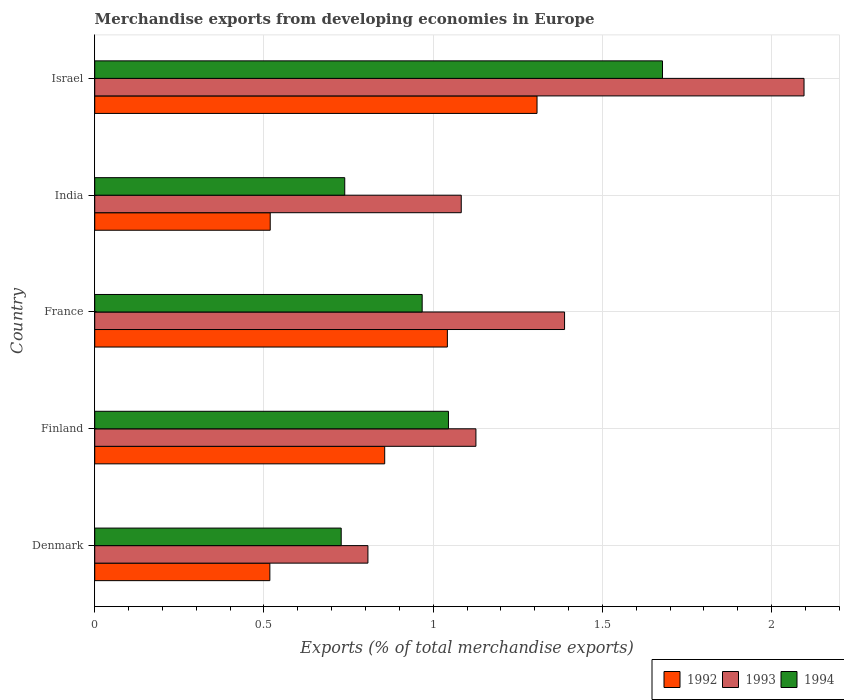How many different coloured bars are there?
Your response must be concise. 3. Are the number of bars per tick equal to the number of legend labels?
Your answer should be compact. Yes. Are the number of bars on each tick of the Y-axis equal?
Provide a succinct answer. Yes. What is the label of the 2nd group of bars from the top?
Provide a short and direct response. India. What is the percentage of total merchandise exports in 1994 in Finland?
Provide a succinct answer. 1.05. Across all countries, what is the maximum percentage of total merchandise exports in 1994?
Give a very brief answer. 1.68. Across all countries, what is the minimum percentage of total merchandise exports in 1994?
Ensure brevity in your answer.  0.73. What is the total percentage of total merchandise exports in 1992 in the graph?
Provide a succinct answer. 4.24. What is the difference between the percentage of total merchandise exports in 1992 in India and that in Israel?
Keep it short and to the point. -0.79. What is the difference between the percentage of total merchandise exports in 1992 in Israel and the percentage of total merchandise exports in 1993 in Denmark?
Offer a very short reply. 0.5. What is the average percentage of total merchandise exports in 1994 per country?
Provide a short and direct response. 1.03. What is the difference between the percentage of total merchandise exports in 1993 and percentage of total merchandise exports in 1994 in France?
Provide a succinct answer. 0.42. What is the ratio of the percentage of total merchandise exports in 1994 in Finland to that in Israel?
Your answer should be very brief. 0.62. Is the difference between the percentage of total merchandise exports in 1993 in Denmark and Israel greater than the difference between the percentage of total merchandise exports in 1994 in Denmark and Israel?
Keep it short and to the point. No. What is the difference between the highest and the second highest percentage of total merchandise exports in 1992?
Keep it short and to the point. 0.26. What is the difference between the highest and the lowest percentage of total merchandise exports in 1994?
Your answer should be compact. 0.95. Is the sum of the percentage of total merchandise exports in 1992 in Finland and Israel greater than the maximum percentage of total merchandise exports in 1993 across all countries?
Your answer should be compact. Yes. Are all the bars in the graph horizontal?
Ensure brevity in your answer.  Yes. How many countries are there in the graph?
Provide a succinct answer. 5. Are the values on the major ticks of X-axis written in scientific E-notation?
Offer a terse response. No. Does the graph contain grids?
Give a very brief answer. Yes. Where does the legend appear in the graph?
Make the answer very short. Bottom right. What is the title of the graph?
Offer a very short reply. Merchandise exports from developing economies in Europe. Does "1978" appear as one of the legend labels in the graph?
Offer a very short reply. No. What is the label or title of the X-axis?
Provide a short and direct response. Exports (% of total merchandise exports). What is the label or title of the Y-axis?
Offer a very short reply. Country. What is the Exports (% of total merchandise exports) of 1992 in Denmark?
Your answer should be very brief. 0.52. What is the Exports (% of total merchandise exports) in 1993 in Denmark?
Ensure brevity in your answer.  0.81. What is the Exports (% of total merchandise exports) of 1994 in Denmark?
Offer a very short reply. 0.73. What is the Exports (% of total merchandise exports) of 1992 in Finland?
Offer a terse response. 0.86. What is the Exports (% of total merchandise exports) of 1993 in Finland?
Your answer should be very brief. 1.13. What is the Exports (% of total merchandise exports) of 1994 in Finland?
Provide a succinct answer. 1.05. What is the Exports (% of total merchandise exports) in 1992 in France?
Provide a short and direct response. 1.04. What is the Exports (% of total merchandise exports) in 1993 in France?
Your answer should be very brief. 1.39. What is the Exports (% of total merchandise exports) in 1994 in France?
Provide a short and direct response. 0.97. What is the Exports (% of total merchandise exports) in 1992 in India?
Ensure brevity in your answer.  0.52. What is the Exports (% of total merchandise exports) in 1993 in India?
Make the answer very short. 1.08. What is the Exports (% of total merchandise exports) in 1994 in India?
Your answer should be compact. 0.74. What is the Exports (% of total merchandise exports) of 1992 in Israel?
Ensure brevity in your answer.  1.31. What is the Exports (% of total merchandise exports) of 1993 in Israel?
Offer a terse response. 2.1. What is the Exports (% of total merchandise exports) in 1994 in Israel?
Provide a succinct answer. 1.68. Across all countries, what is the maximum Exports (% of total merchandise exports) of 1992?
Ensure brevity in your answer.  1.31. Across all countries, what is the maximum Exports (% of total merchandise exports) of 1993?
Your answer should be very brief. 2.1. Across all countries, what is the maximum Exports (% of total merchandise exports) of 1994?
Your answer should be compact. 1.68. Across all countries, what is the minimum Exports (% of total merchandise exports) in 1992?
Make the answer very short. 0.52. Across all countries, what is the minimum Exports (% of total merchandise exports) of 1993?
Give a very brief answer. 0.81. Across all countries, what is the minimum Exports (% of total merchandise exports) of 1994?
Provide a succinct answer. 0.73. What is the total Exports (% of total merchandise exports) of 1992 in the graph?
Your answer should be compact. 4.24. What is the total Exports (% of total merchandise exports) of 1993 in the graph?
Give a very brief answer. 6.5. What is the total Exports (% of total merchandise exports) of 1994 in the graph?
Give a very brief answer. 5.16. What is the difference between the Exports (% of total merchandise exports) in 1992 in Denmark and that in Finland?
Make the answer very short. -0.34. What is the difference between the Exports (% of total merchandise exports) in 1993 in Denmark and that in Finland?
Provide a succinct answer. -0.32. What is the difference between the Exports (% of total merchandise exports) of 1994 in Denmark and that in Finland?
Ensure brevity in your answer.  -0.32. What is the difference between the Exports (% of total merchandise exports) of 1992 in Denmark and that in France?
Keep it short and to the point. -0.52. What is the difference between the Exports (% of total merchandise exports) of 1993 in Denmark and that in France?
Ensure brevity in your answer.  -0.58. What is the difference between the Exports (% of total merchandise exports) in 1994 in Denmark and that in France?
Provide a short and direct response. -0.24. What is the difference between the Exports (% of total merchandise exports) in 1992 in Denmark and that in India?
Your answer should be very brief. -0. What is the difference between the Exports (% of total merchandise exports) of 1993 in Denmark and that in India?
Keep it short and to the point. -0.28. What is the difference between the Exports (% of total merchandise exports) in 1994 in Denmark and that in India?
Your answer should be compact. -0.01. What is the difference between the Exports (% of total merchandise exports) of 1992 in Denmark and that in Israel?
Offer a terse response. -0.79. What is the difference between the Exports (% of total merchandise exports) of 1993 in Denmark and that in Israel?
Provide a succinct answer. -1.29. What is the difference between the Exports (% of total merchandise exports) of 1994 in Denmark and that in Israel?
Ensure brevity in your answer.  -0.95. What is the difference between the Exports (% of total merchandise exports) of 1992 in Finland and that in France?
Give a very brief answer. -0.19. What is the difference between the Exports (% of total merchandise exports) of 1993 in Finland and that in France?
Keep it short and to the point. -0.26. What is the difference between the Exports (% of total merchandise exports) in 1994 in Finland and that in France?
Provide a short and direct response. 0.08. What is the difference between the Exports (% of total merchandise exports) of 1992 in Finland and that in India?
Offer a terse response. 0.34. What is the difference between the Exports (% of total merchandise exports) in 1993 in Finland and that in India?
Your answer should be compact. 0.04. What is the difference between the Exports (% of total merchandise exports) of 1994 in Finland and that in India?
Make the answer very short. 0.31. What is the difference between the Exports (% of total merchandise exports) of 1992 in Finland and that in Israel?
Ensure brevity in your answer.  -0.45. What is the difference between the Exports (% of total merchandise exports) of 1993 in Finland and that in Israel?
Offer a terse response. -0.97. What is the difference between the Exports (% of total merchandise exports) of 1994 in Finland and that in Israel?
Your answer should be very brief. -0.63. What is the difference between the Exports (% of total merchandise exports) of 1992 in France and that in India?
Your response must be concise. 0.52. What is the difference between the Exports (% of total merchandise exports) of 1993 in France and that in India?
Provide a short and direct response. 0.31. What is the difference between the Exports (% of total merchandise exports) of 1994 in France and that in India?
Keep it short and to the point. 0.23. What is the difference between the Exports (% of total merchandise exports) in 1992 in France and that in Israel?
Provide a short and direct response. -0.26. What is the difference between the Exports (% of total merchandise exports) of 1993 in France and that in Israel?
Keep it short and to the point. -0.71. What is the difference between the Exports (% of total merchandise exports) of 1994 in France and that in Israel?
Offer a terse response. -0.71. What is the difference between the Exports (% of total merchandise exports) of 1992 in India and that in Israel?
Provide a short and direct response. -0.79. What is the difference between the Exports (% of total merchandise exports) in 1993 in India and that in Israel?
Your answer should be compact. -1.01. What is the difference between the Exports (% of total merchandise exports) of 1994 in India and that in Israel?
Offer a very short reply. -0.94. What is the difference between the Exports (% of total merchandise exports) in 1992 in Denmark and the Exports (% of total merchandise exports) in 1993 in Finland?
Your answer should be very brief. -0.61. What is the difference between the Exports (% of total merchandise exports) in 1992 in Denmark and the Exports (% of total merchandise exports) in 1994 in Finland?
Your answer should be compact. -0.53. What is the difference between the Exports (% of total merchandise exports) of 1993 in Denmark and the Exports (% of total merchandise exports) of 1994 in Finland?
Your answer should be compact. -0.24. What is the difference between the Exports (% of total merchandise exports) of 1992 in Denmark and the Exports (% of total merchandise exports) of 1993 in France?
Your answer should be compact. -0.87. What is the difference between the Exports (% of total merchandise exports) of 1992 in Denmark and the Exports (% of total merchandise exports) of 1994 in France?
Give a very brief answer. -0.45. What is the difference between the Exports (% of total merchandise exports) in 1993 in Denmark and the Exports (% of total merchandise exports) in 1994 in France?
Give a very brief answer. -0.16. What is the difference between the Exports (% of total merchandise exports) in 1992 in Denmark and the Exports (% of total merchandise exports) in 1993 in India?
Keep it short and to the point. -0.57. What is the difference between the Exports (% of total merchandise exports) in 1992 in Denmark and the Exports (% of total merchandise exports) in 1994 in India?
Your response must be concise. -0.22. What is the difference between the Exports (% of total merchandise exports) in 1993 in Denmark and the Exports (% of total merchandise exports) in 1994 in India?
Your response must be concise. 0.07. What is the difference between the Exports (% of total merchandise exports) of 1992 in Denmark and the Exports (% of total merchandise exports) of 1993 in Israel?
Your answer should be very brief. -1.58. What is the difference between the Exports (% of total merchandise exports) in 1992 in Denmark and the Exports (% of total merchandise exports) in 1994 in Israel?
Offer a very short reply. -1.16. What is the difference between the Exports (% of total merchandise exports) of 1993 in Denmark and the Exports (% of total merchandise exports) of 1994 in Israel?
Your answer should be compact. -0.87. What is the difference between the Exports (% of total merchandise exports) in 1992 in Finland and the Exports (% of total merchandise exports) in 1993 in France?
Provide a succinct answer. -0.53. What is the difference between the Exports (% of total merchandise exports) in 1992 in Finland and the Exports (% of total merchandise exports) in 1994 in France?
Provide a short and direct response. -0.11. What is the difference between the Exports (% of total merchandise exports) in 1993 in Finland and the Exports (% of total merchandise exports) in 1994 in France?
Your response must be concise. 0.16. What is the difference between the Exports (% of total merchandise exports) of 1992 in Finland and the Exports (% of total merchandise exports) of 1993 in India?
Keep it short and to the point. -0.23. What is the difference between the Exports (% of total merchandise exports) of 1992 in Finland and the Exports (% of total merchandise exports) of 1994 in India?
Ensure brevity in your answer.  0.12. What is the difference between the Exports (% of total merchandise exports) of 1993 in Finland and the Exports (% of total merchandise exports) of 1994 in India?
Your response must be concise. 0.39. What is the difference between the Exports (% of total merchandise exports) of 1992 in Finland and the Exports (% of total merchandise exports) of 1993 in Israel?
Provide a short and direct response. -1.24. What is the difference between the Exports (% of total merchandise exports) in 1992 in Finland and the Exports (% of total merchandise exports) in 1994 in Israel?
Make the answer very short. -0.82. What is the difference between the Exports (% of total merchandise exports) of 1993 in Finland and the Exports (% of total merchandise exports) of 1994 in Israel?
Keep it short and to the point. -0.55. What is the difference between the Exports (% of total merchandise exports) of 1992 in France and the Exports (% of total merchandise exports) of 1993 in India?
Your response must be concise. -0.04. What is the difference between the Exports (% of total merchandise exports) of 1992 in France and the Exports (% of total merchandise exports) of 1994 in India?
Your answer should be very brief. 0.3. What is the difference between the Exports (% of total merchandise exports) of 1993 in France and the Exports (% of total merchandise exports) of 1994 in India?
Your answer should be compact. 0.65. What is the difference between the Exports (% of total merchandise exports) in 1992 in France and the Exports (% of total merchandise exports) in 1993 in Israel?
Your answer should be very brief. -1.05. What is the difference between the Exports (% of total merchandise exports) of 1992 in France and the Exports (% of total merchandise exports) of 1994 in Israel?
Your response must be concise. -0.64. What is the difference between the Exports (% of total merchandise exports) of 1993 in France and the Exports (% of total merchandise exports) of 1994 in Israel?
Keep it short and to the point. -0.29. What is the difference between the Exports (% of total merchandise exports) of 1992 in India and the Exports (% of total merchandise exports) of 1993 in Israel?
Offer a very short reply. -1.58. What is the difference between the Exports (% of total merchandise exports) in 1992 in India and the Exports (% of total merchandise exports) in 1994 in Israel?
Offer a very short reply. -1.16. What is the difference between the Exports (% of total merchandise exports) of 1993 in India and the Exports (% of total merchandise exports) of 1994 in Israel?
Keep it short and to the point. -0.59. What is the average Exports (% of total merchandise exports) of 1992 per country?
Offer a very short reply. 0.85. What is the average Exports (% of total merchandise exports) in 1993 per country?
Provide a succinct answer. 1.3. What is the average Exports (% of total merchandise exports) of 1994 per country?
Keep it short and to the point. 1.03. What is the difference between the Exports (% of total merchandise exports) of 1992 and Exports (% of total merchandise exports) of 1993 in Denmark?
Provide a short and direct response. -0.29. What is the difference between the Exports (% of total merchandise exports) of 1992 and Exports (% of total merchandise exports) of 1994 in Denmark?
Provide a short and direct response. -0.21. What is the difference between the Exports (% of total merchandise exports) in 1993 and Exports (% of total merchandise exports) in 1994 in Denmark?
Your answer should be compact. 0.08. What is the difference between the Exports (% of total merchandise exports) in 1992 and Exports (% of total merchandise exports) in 1993 in Finland?
Keep it short and to the point. -0.27. What is the difference between the Exports (% of total merchandise exports) in 1992 and Exports (% of total merchandise exports) in 1994 in Finland?
Ensure brevity in your answer.  -0.19. What is the difference between the Exports (% of total merchandise exports) of 1993 and Exports (% of total merchandise exports) of 1994 in Finland?
Your response must be concise. 0.08. What is the difference between the Exports (% of total merchandise exports) in 1992 and Exports (% of total merchandise exports) in 1993 in France?
Ensure brevity in your answer.  -0.35. What is the difference between the Exports (% of total merchandise exports) in 1992 and Exports (% of total merchandise exports) in 1994 in France?
Your answer should be compact. 0.07. What is the difference between the Exports (% of total merchandise exports) in 1993 and Exports (% of total merchandise exports) in 1994 in France?
Provide a succinct answer. 0.42. What is the difference between the Exports (% of total merchandise exports) in 1992 and Exports (% of total merchandise exports) in 1993 in India?
Your answer should be compact. -0.56. What is the difference between the Exports (% of total merchandise exports) of 1992 and Exports (% of total merchandise exports) of 1994 in India?
Offer a terse response. -0.22. What is the difference between the Exports (% of total merchandise exports) of 1993 and Exports (% of total merchandise exports) of 1994 in India?
Provide a succinct answer. 0.34. What is the difference between the Exports (% of total merchandise exports) of 1992 and Exports (% of total merchandise exports) of 1993 in Israel?
Your response must be concise. -0.79. What is the difference between the Exports (% of total merchandise exports) of 1992 and Exports (% of total merchandise exports) of 1994 in Israel?
Provide a succinct answer. -0.37. What is the difference between the Exports (% of total merchandise exports) in 1993 and Exports (% of total merchandise exports) in 1994 in Israel?
Make the answer very short. 0.42. What is the ratio of the Exports (% of total merchandise exports) in 1992 in Denmark to that in Finland?
Provide a short and direct response. 0.6. What is the ratio of the Exports (% of total merchandise exports) of 1993 in Denmark to that in Finland?
Provide a succinct answer. 0.72. What is the ratio of the Exports (% of total merchandise exports) of 1994 in Denmark to that in Finland?
Offer a terse response. 0.7. What is the ratio of the Exports (% of total merchandise exports) in 1992 in Denmark to that in France?
Provide a short and direct response. 0.5. What is the ratio of the Exports (% of total merchandise exports) in 1993 in Denmark to that in France?
Provide a short and direct response. 0.58. What is the ratio of the Exports (% of total merchandise exports) of 1994 in Denmark to that in France?
Give a very brief answer. 0.75. What is the ratio of the Exports (% of total merchandise exports) in 1992 in Denmark to that in India?
Keep it short and to the point. 1. What is the ratio of the Exports (% of total merchandise exports) of 1993 in Denmark to that in India?
Your answer should be compact. 0.75. What is the ratio of the Exports (% of total merchandise exports) of 1994 in Denmark to that in India?
Give a very brief answer. 0.99. What is the ratio of the Exports (% of total merchandise exports) of 1992 in Denmark to that in Israel?
Your response must be concise. 0.4. What is the ratio of the Exports (% of total merchandise exports) of 1993 in Denmark to that in Israel?
Provide a short and direct response. 0.39. What is the ratio of the Exports (% of total merchandise exports) of 1994 in Denmark to that in Israel?
Provide a succinct answer. 0.43. What is the ratio of the Exports (% of total merchandise exports) of 1992 in Finland to that in France?
Give a very brief answer. 0.82. What is the ratio of the Exports (% of total merchandise exports) in 1993 in Finland to that in France?
Your answer should be compact. 0.81. What is the ratio of the Exports (% of total merchandise exports) of 1994 in Finland to that in France?
Make the answer very short. 1.08. What is the ratio of the Exports (% of total merchandise exports) of 1992 in Finland to that in India?
Ensure brevity in your answer.  1.65. What is the ratio of the Exports (% of total merchandise exports) of 1993 in Finland to that in India?
Offer a terse response. 1.04. What is the ratio of the Exports (% of total merchandise exports) of 1994 in Finland to that in India?
Give a very brief answer. 1.41. What is the ratio of the Exports (% of total merchandise exports) of 1992 in Finland to that in Israel?
Keep it short and to the point. 0.66. What is the ratio of the Exports (% of total merchandise exports) in 1993 in Finland to that in Israel?
Offer a very short reply. 0.54. What is the ratio of the Exports (% of total merchandise exports) in 1994 in Finland to that in Israel?
Give a very brief answer. 0.62. What is the ratio of the Exports (% of total merchandise exports) in 1992 in France to that in India?
Offer a terse response. 2.01. What is the ratio of the Exports (% of total merchandise exports) in 1993 in France to that in India?
Your response must be concise. 1.28. What is the ratio of the Exports (% of total merchandise exports) in 1994 in France to that in India?
Ensure brevity in your answer.  1.31. What is the ratio of the Exports (% of total merchandise exports) in 1992 in France to that in Israel?
Offer a very short reply. 0.8. What is the ratio of the Exports (% of total merchandise exports) of 1993 in France to that in Israel?
Make the answer very short. 0.66. What is the ratio of the Exports (% of total merchandise exports) in 1994 in France to that in Israel?
Offer a very short reply. 0.58. What is the ratio of the Exports (% of total merchandise exports) in 1992 in India to that in Israel?
Keep it short and to the point. 0.4. What is the ratio of the Exports (% of total merchandise exports) of 1993 in India to that in Israel?
Provide a succinct answer. 0.52. What is the ratio of the Exports (% of total merchandise exports) of 1994 in India to that in Israel?
Your response must be concise. 0.44. What is the difference between the highest and the second highest Exports (% of total merchandise exports) of 1992?
Your response must be concise. 0.26. What is the difference between the highest and the second highest Exports (% of total merchandise exports) of 1993?
Provide a short and direct response. 0.71. What is the difference between the highest and the second highest Exports (% of total merchandise exports) in 1994?
Give a very brief answer. 0.63. What is the difference between the highest and the lowest Exports (% of total merchandise exports) in 1992?
Give a very brief answer. 0.79. What is the difference between the highest and the lowest Exports (% of total merchandise exports) in 1993?
Offer a very short reply. 1.29. What is the difference between the highest and the lowest Exports (% of total merchandise exports) of 1994?
Your response must be concise. 0.95. 